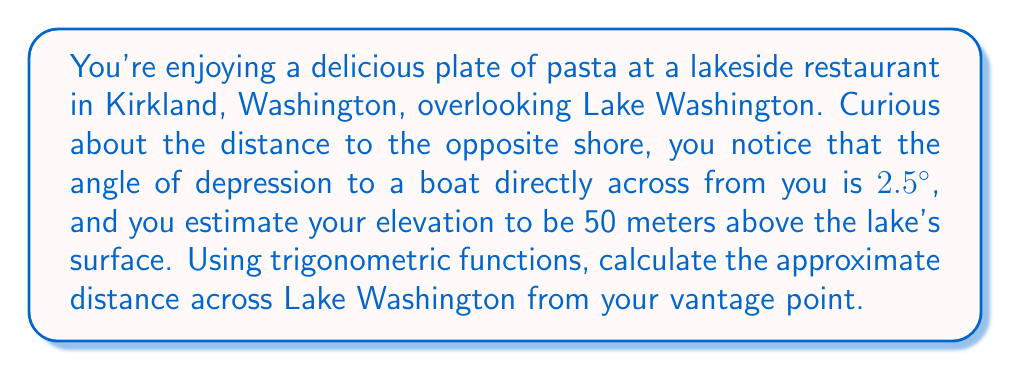Teach me how to tackle this problem. Let's approach this step-by-step using trigonometry:

1) First, let's visualize the problem:

[asy]
import geometry;

size(200);
pair A = (0,0), B = (200,0), C = (0,20);
draw(A--B--C--A);
label("Lake surface", (100,0), S);
label("You", C, NW);
label("Opposite shore", B, E);
label("50 m", (0,10), W);
label("2.5°", C, SE);
label("x", (100,-10), S);
[/asy]

2) We can use the tangent function to solve this problem. The tangent of an angle in a right triangle is the ratio of the opposite side to the adjacent side.

3) In this case:
   - The angle is 2.5°
   - The opposite side is your height above the lake (50 meters)
   - The adjacent side is the distance across the lake (let's call this x)

4) We can write this as an equation:

   $$\tan(2.5°) = \frac{50}{x}$$

5) To solve for x, we multiply both sides by x and then divide by tan(2.5°):

   $$x = \frac{50}{\tan(2.5°)}$$

6) Now we can calculate this:
   
   $$x = \frac{50}{\tan(2.5°)} \approx 1145.47 \text{ meters}$$

7) Rounding to the nearest meter, we get 1145 meters.
Answer: 1145 meters 